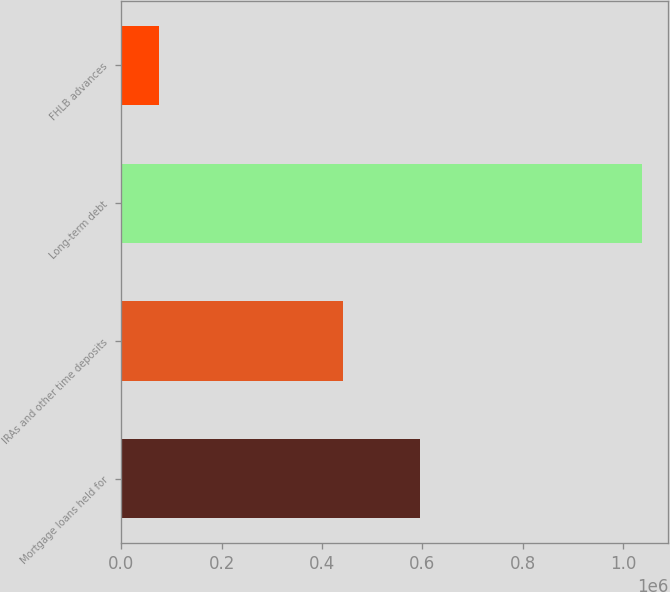Convert chart. <chart><loc_0><loc_0><loc_500><loc_500><bar_chart><fcel>Mortgage loans held for<fcel>IRAs and other time deposits<fcel>Long-term debt<fcel>FHLB advances<nl><fcel>595405<fcel>442252<fcel>1.03883e+06<fcel>75000<nl></chart> 